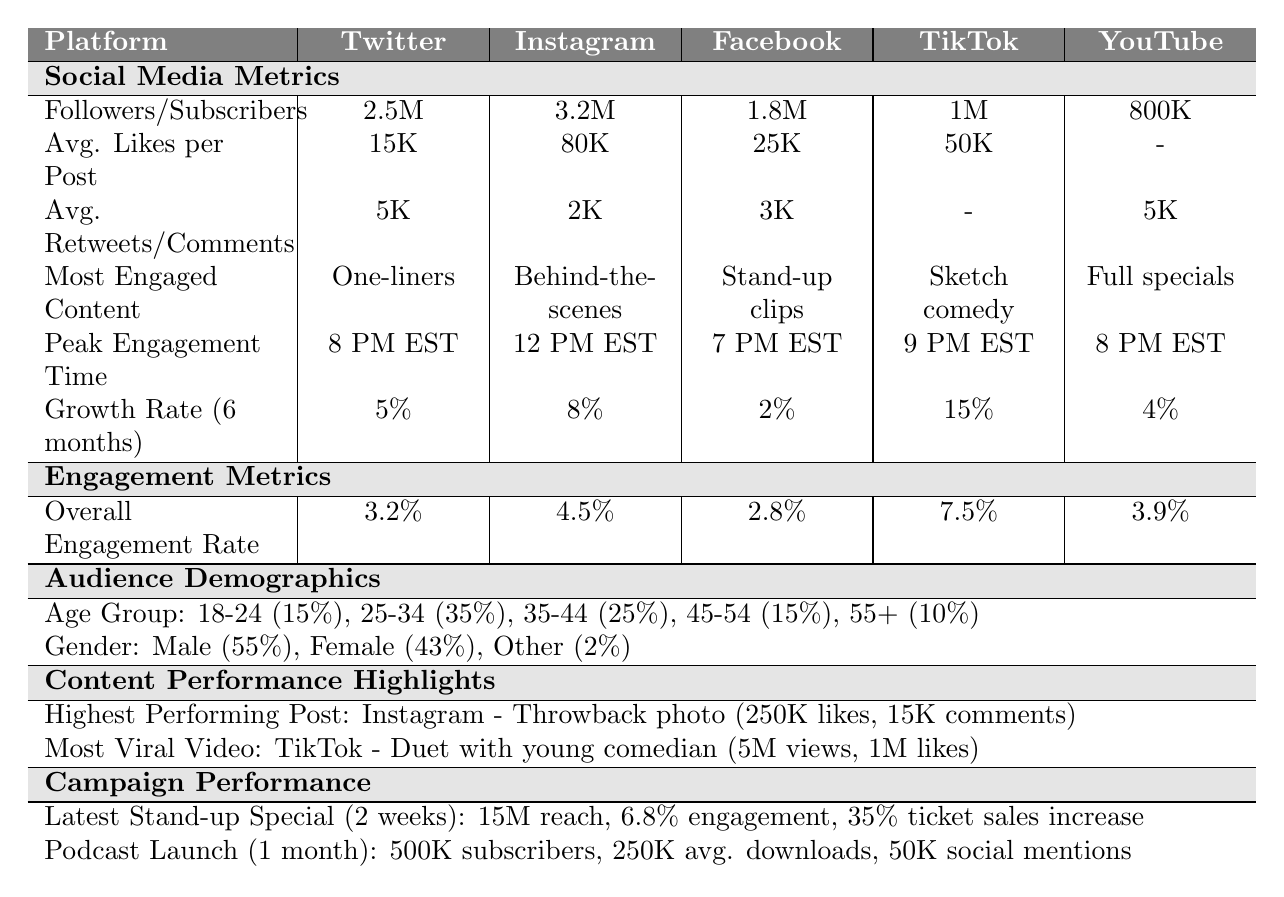What is the most engaged content type on Instagram? The table indicates that the most engaged content type on Instagram is "Behind-the-scenes photos."
Answer: Behind-the-scenes photos What is the average number of likes per post on Twitter? The table shows that the average number of likes per post on Twitter is 15,000.
Answer: 15,000 Which platform has the highest overall engagement rate? According to the table, TikTok has the highest overall engagement rate at 7.5%.
Answer: TikTok What is the difference in followers between Instagram and TikTok? Instagram has 3.2 million followers and TikTok has 1 million followers. The difference is 3.2M - 1M = 2.2M.
Answer: 2.2 million Is the growth rate on Facebook higher than on Twitter? The growth rate on Facebook is 2% while on Twitter it is 5%. Since 2% is less than 5%, the answer is no.
Answer: No What time is peak engagement on Facebook? The table states that the peak engagement time on Facebook is 7 PM EST.
Answer: 7 PM EST Which platform gained the most TikTok followers in the last 6 months? TikTok has the highest growth rate at 15% indicating it gained the most followers compared to others.
Answer: TikTok What percentage of the audience demographic is aged 25-34? The table indicates that 35% of the audience is aged 25-34.
Answer: 35% What are the average reactions per post on Facebook? The table shows that the average reactions per post on Facebook is 25,000.
Answer: 25,000 Which campaign is more effective in terms of social media mentions? The Podcast Launch garnered 50,000 social media mentions, more than the 50,000 mentions for the Latest Stand-up Special.
Answer: Podcast Launch If the total reach of the latest stand-up special was 15 million, what percentage engagement rate did it achieve? The engagement rate for the latest stand-up special is provided in the table as 6.8%.
Answer: 6.8% 